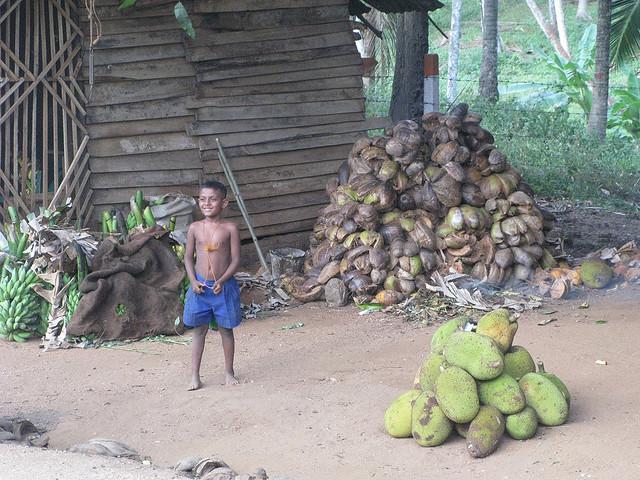What type of fruit are the green items on the boys right?
Choose the correct response, then elucidate: 'Answer: answer
Rationale: rationale.'
Options: Bananas, potatoes, papayas, turnips. Answer: bananas.
Rationale: The fruit on the boy's right are the bananas to our left. 